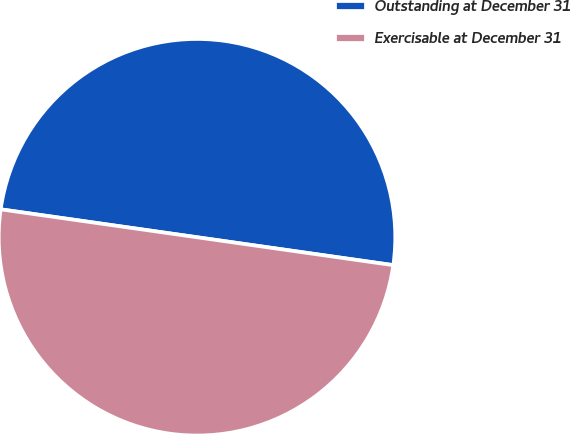<chart> <loc_0><loc_0><loc_500><loc_500><pie_chart><fcel>Outstanding at December 31<fcel>Exercisable at December 31<nl><fcel>50.0%<fcel>50.0%<nl></chart> 